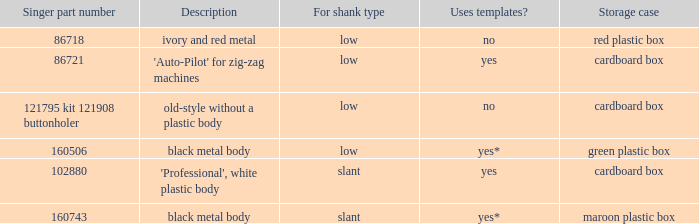What are all the different descriptions for the buttonholer with cardboard box for storage and a low shank type? 'Auto-Pilot' for zig-zag machines, old-style without a plastic body. 